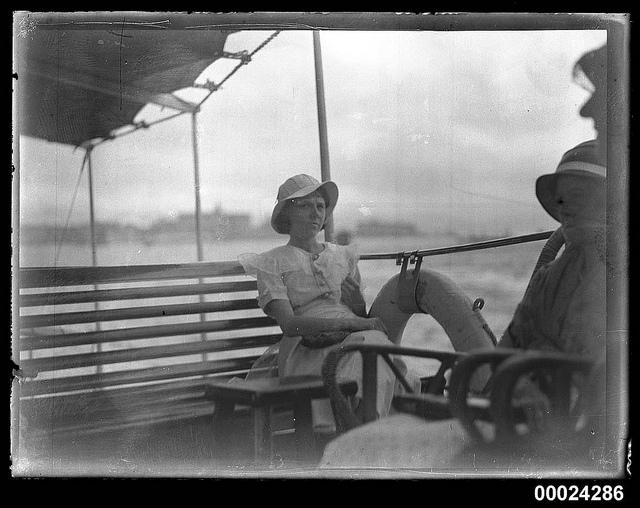Is the lady smiling?
Write a very short answer. No. Is this lady in a car?
Concise answer only. No. Is the photo in black and white?
Short answer required. Yes. 